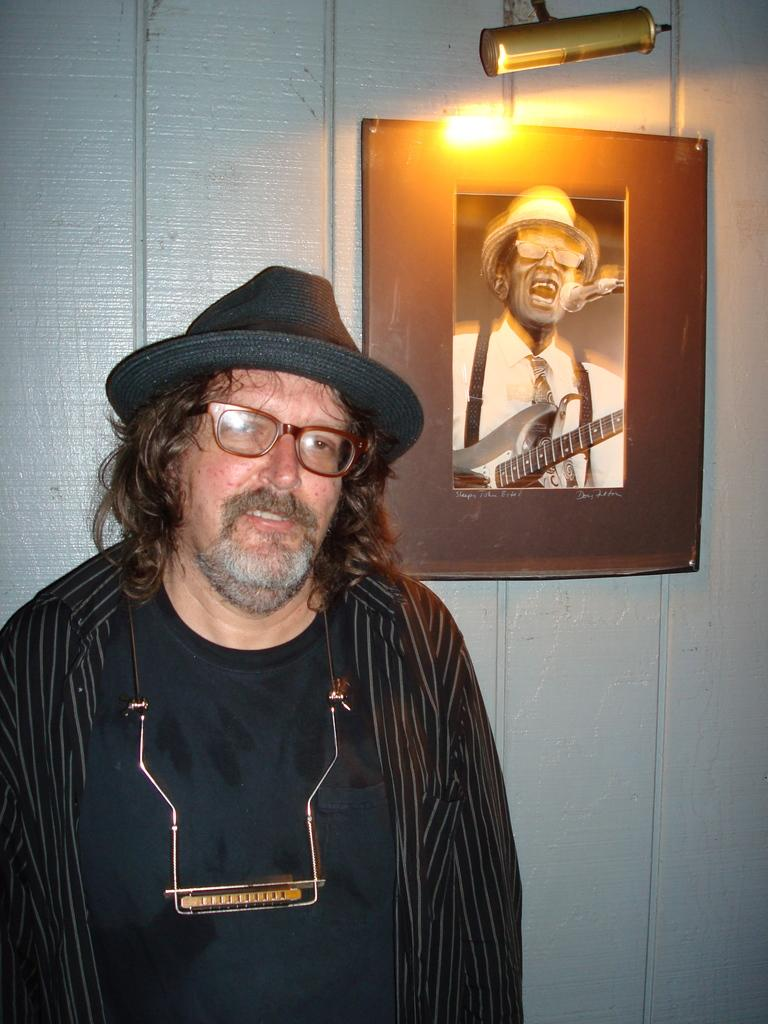What is the main subject of the image? There is a man standing in the image. What can be seen behind the man? There is a photo frame visible behind the man. Can you describe the lighting in the image? Light is present in the image. What type of vacation is the man planning based on the image? There is no information about a vacation in the image, so it cannot be determined. What does the man's tongue look like in the image? The man's tongue is not visible in the image, so it cannot be described. 